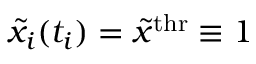Convert formula to latex. <formula><loc_0><loc_0><loc_500><loc_500>{ \tilde { x } } _ { i } ( t _ { i } ) = { \tilde { x } } ^ { t h r } \equiv 1</formula> 